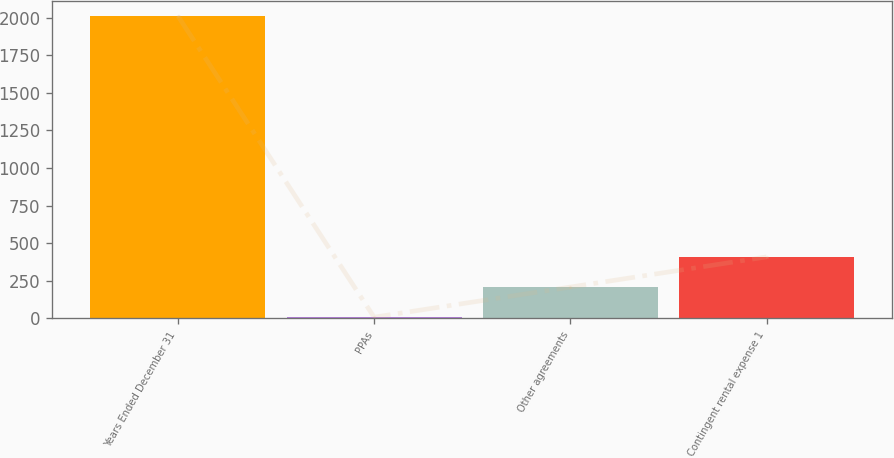<chart> <loc_0><loc_0><loc_500><loc_500><bar_chart><fcel>Years Ended December 31<fcel>PPAs<fcel>Other agreements<fcel>Contingent rental expense 1<nl><fcel>2013<fcel>6<fcel>206.7<fcel>407.4<nl></chart> 